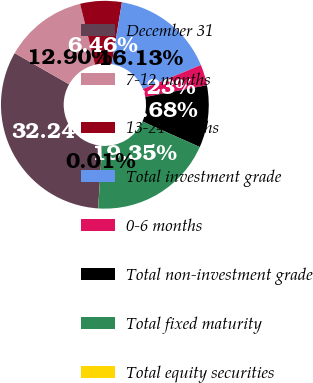<chart> <loc_0><loc_0><loc_500><loc_500><pie_chart><fcel>December 31<fcel>7-12 months<fcel>13-24 months<fcel>Total investment grade<fcel>0-6 months<fcel>Total non-investment grade<fcel>Total fixed maturity<fcel>Total equity securities<nl><fcel>32.24%<fcel>12.9%<fcel>6.46%<fcel>16.13%<fcel>3.23%<fcel>9.68%<fcel>19.35%<fcel>0.01%<nl></chart> 